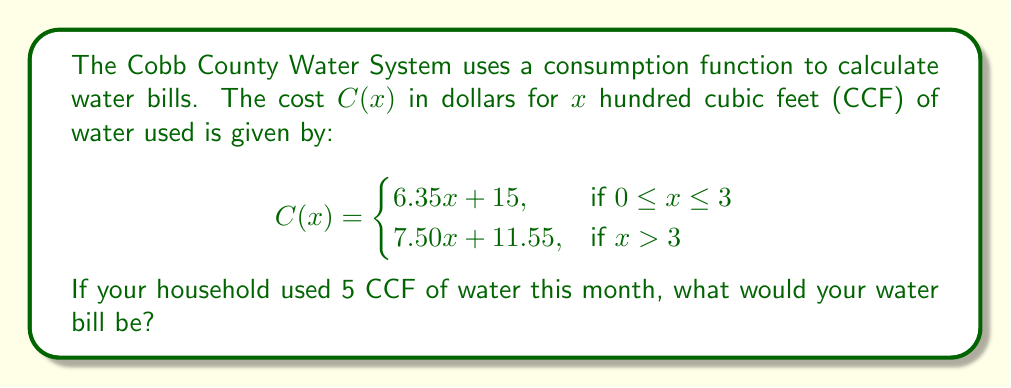What is the answer to this math problem? Let's approach this step-by-step:

1) We need to determine which part of the piecewise function to use. Since our water usage (x) is 5 CCF, and 5 > 3, we'll use the second part of the function:

   $$C(x) = 7.50x + 11.55$$

2) Now, we substitute x = 5 into this equation:

   $$C(5) = 7.50(5) + 11.55$$

3) Let's calculate:
   
   $$C(5) = 37.50 + 11.55$$

4) Finally, we sum these values:

   $$C(5) = 49.05$$

Therefore, the water bill for using 5 CCF of water would be $49.05.
Answer: $49.05 